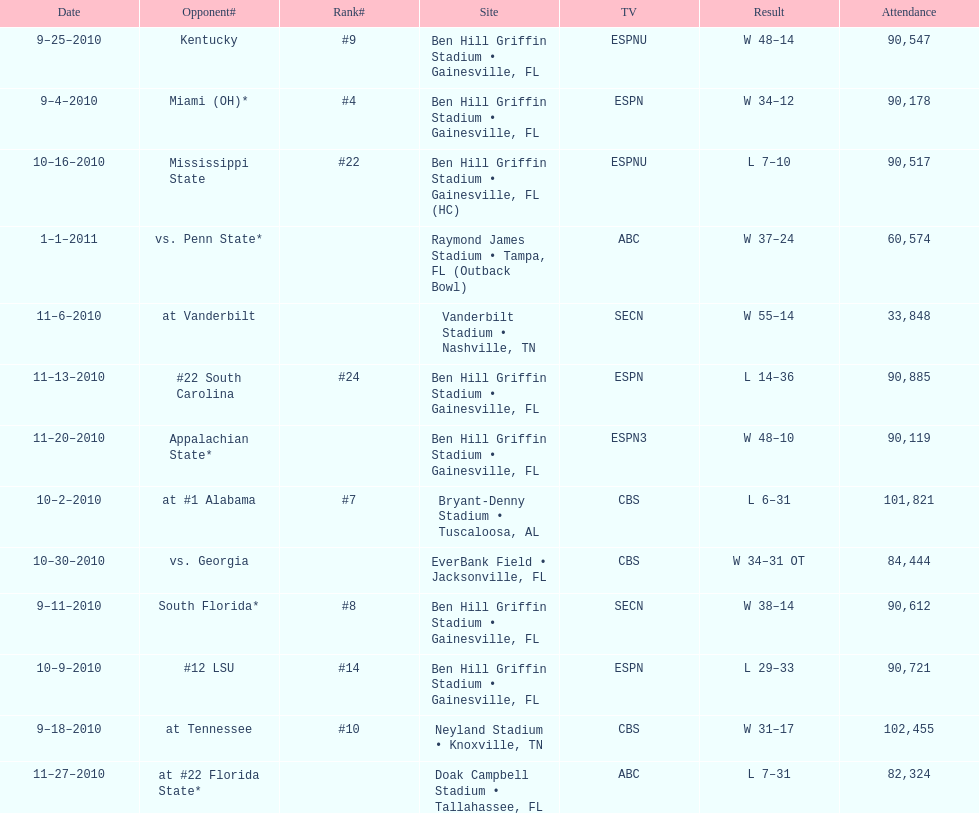What is the number of games played in teh 2010-2011 season 13. 